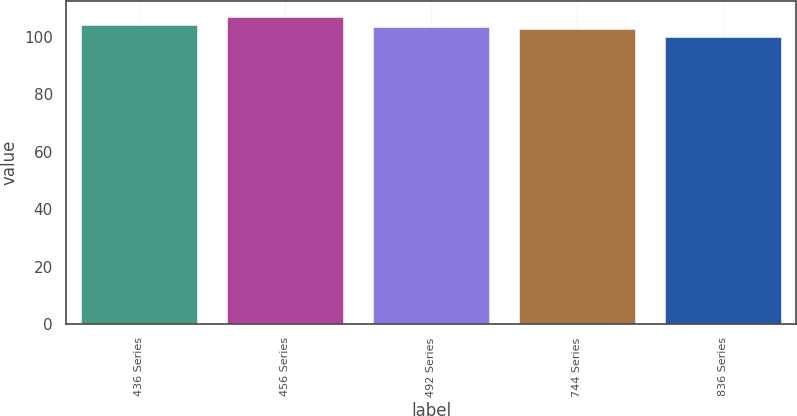<chart> <loc_0><loc_0><loc_500><loc_500><bar_chart><fcel>436 Series<fcel>456 Series<fcel>492 Series<fcel>744 Series<fcel>836 Series<nl><fcel>104.21<fcel>107<fcel>103.51<fcel>102.81<fcel>100<nl></chart> 